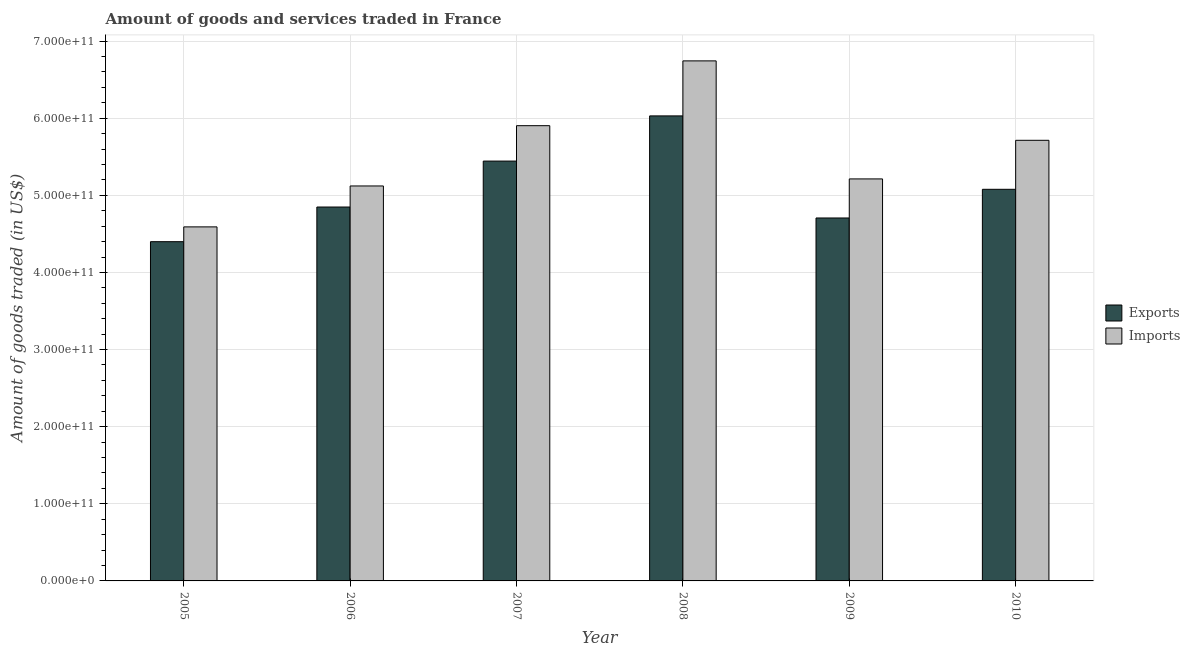How many different coloured bars are there?
Provide a short and direct response. 2. How many groups of bars are there?
Provide a succinct answer. 6. Are the number of bars on each tick of the X-axis equal?
Keep it short and to the point. Yes. How many bars are there on the 4th tick from the left?
Give a very brief answer. 2. How many bars are there on the 4th tick from the right?
Your answer should be compact. 2. What is the amount of goods imported in 2009?
Provide a succinct answer. 5.21e+11. Across all years, what is the maximum amount of goods exported?
Ensure brevity in your answer.  6.03e+11. Across all years, what is the minimum amount of goods exported?
Give a very brief answer. 4.40e+11. What is the total amount of goods imported in the graph?
Your answer should be compact. 3.33e+12. What is the difference between the amount of goods exported in 2005 and that in 2006?
Keep it short and to the point. -4.50e+1. What is the difference between the amount of goods imported in 2008 and the amount of goods exported in 2007?
Make the answer very short. 8.40e+1. What is the average amount of goods exported per year?
Your response must be concise. 5.08e+11. In how many years, is the amount of goods imported greater than 260000000000 US$?
Offer a terse response. 6. What is the ratio of the amount of goods imported in 2006 to that in 2008?
Offer a terse response. 0.76. Is the amount of goods exported in 2008 less than that in 2010?
Provide a short and direct response. No. What is the difference between the highest and the second highest amount of goods exported?
Offer a terse response. 5.86e+1. What is the difference between the highest and the lowest amount of goods imported?
Provide a short and direct response. 2.15e+11. Is the sum of the amount of goods imported in 2007 and 2009 greater than the maximum amount of goods exported across all years?
Make the answer very short. Yes. What does the 1st bar from the left in 2010 represents?
Offer a very short reply. Exports. What does the 1st bar from the right in 2009 represents?
Give a very brief answer. Imports. Are all the bars in the graph horizontal?
Keep it short and to the point. No. What is the difference between two consecutive major ticks on the Y-axis?
Your response must be concise. 1.00e+11. Does the graph contain any zero values?
Offer a very short reply. No. Where does the legend appear in the graph?
Your answer should be compact. Center right. How many legend labels are there?
Give a very brief answer. 2. What is the title of the graph?
Offer a terse response. Amount of goods and services traded in France. Does "Female labor force" appear as one of the legend labels in the graph?
Make the answer very short. No. What is the label or title of the X-axis?
Provide a short and direct response. Year. What is the label or title of the Y-axis?
Your response must be concise. Amount of goods traded (in US$). What is the Amount of goods traded (in US$) in Exports in 2005?
Offer a terse response. 4.40e+11. What is the Amount of goods traded (in US$) of Imports in 2005?
Offer a very short reply. 4.59e+11. What is the Amount of goods traded (in US$) in Exports in 2006?
Give a very brief answer. 4.85e+11. What is the Amount of goods traded (in US$) of Imports in 2006?
Offer a very short reply. 5.12e+11. What is the Amount of goods traded (in US$) of Exports in 2007?
Keep it short and to the point. 5.44e+11. What is the Amount of goods traded (in US$) in Imports in 2007?
Give a very brief answer. 5.90e+11. What is the Amount of goods traded (in US$) in Exports in 2008?
Your answer should be very brief. 6.03e+11. What is the Amount of goods traded (in US$) in Imports in 2008?
Provide a succinct answer. 6.74e+11. What is the Amount of goods traded (in US$) in Exports in 2009?
Provide a succinct answer. 4.71e+11. What is the Amount of goods traded (in US$) of Imports in 2009?
Provide a short and direct response. 5.21e+11. What is the Amount of goods traded (in US$) of Exports in 2010?
Your answer should be compact. 5.08e+11. What is the Amount of goods traded (in US$) in Imports in 2010?
Your response must be concise. 5.71e+11. Across all years, what is the maximum Amount of goods traded (in US$) of Exports?
Make the answer very short. 6.03e+11. Across all years, what is the maximum Amount of goods traded (in US$) in Imports?
Give a very brief answer. 6.74e+11. Across all years, what is the minimum Amount of goods traded (in US$) of Exports?
Keep it short and to the point. 4.40e+11. Across all years, what is the minimum Amount of goods traded (in US$) of Imports?
Provide a succinct answer. 4.59e+11. What is the total Amount of goods traded (in US$) in Exports in the graph?
Give a very brief answer. 3.05e+12. What is the total Amount of goods traded (in US$) of Imports in the graph?
Your response must be concise. 3.33e+12. What is the difference between the Amount of goods traded (in US$) in Exports in 2005 and that in 2006?
Your response must be concise. -4.50e+1. What is the difference between the Amount of goods traded (in US$) of Imports in 2005 and that in 2006?
Keep it short and to the point. -5.30e+1. What is the difference between the Amount of goods traded (in US$) of Exports in 2005 and that in 2007?
Provide a succinct answer. -1.05e+11. What is the difference between the Amount of goods traded (in US$) of Imports in 2005 and that in 2007?
Offer a terse response. -1.31e+11. What is the difference between the Amount of goods traded (in US$) of Exports in 2005 and that in 2008?
Your answer should be very brief. -1.63e+11. What is the difference between the Amount of goods traded (in US$) of Imports in 2005 and that in 2008?
Keep it short and to the point. -2.15e+11. What is the difference between the Amount of goods traded (in US$) in Exports in 2005 and that in 2009?
Offer a very short reply. -3.07e+1. What is the difference between the Amount of goods traded (in US$) in Imports in 2005 and that in 2009?
Ensure brevity in your answer.  -6.22e+1. What is the difference between the Amount of goods traded (in US$) of Exports in 2005 and that in 2010?
Your response must be concise. -6.79e+1. What is the difference between the Amount of goods traded (in US$) in Imports in 2005 and that in 2010?
Provide a short and direct response. -1.12e+11. What is the difference between the Amount of goods traded (in US$) in Exports in 2006 and that in 2007?
Keep it short and to the point. -5.96e+1. What is the difference between the Amount of goods traded (in US$) in Imports in 2006 and that in 2007?
Your answer should be compact. -7.82e+1. What is the difference between the Amount of goods traded (in US$) of Exports in 2006 and that in 2008?
Offer a very short reply. -1.18e+11. What is the difference between the Amount of goods traded (in US$) in Imports in 2006 and that in 2008?
Keep it short and to the point. -1.62e+11. What is the difference between the Amount of goods traded (in US$) in Exports in 2006 and that in 2009?
Provide a short and direct response. 1.42e+1. What is the difference between the Amount of goods traded (in US$) of Imports in 2006 and that in 2009?
Provide a short and direct response. -9.15e+09. What is the difference between the Amount of goods traded (in US$) of Exports in 2006 and that in 2010?
Your response must be concise. -2.30e+1. What is the difference between the Amount of goods traded (in US$) in Imports in 2006 and that in 2010?
Your response must be concise. -5.92e+1. What is the difference between the Amount of goods traded (in US$) in Exports in 2007 and that in 2008?
Provide a succinct answer. -5.86e+1. What is the difference between the Amount of goods traded (in US$) in Imports in 2007 and that in 2008?
Offer a very short reply. -8.40e+1. What is the difference between the Amount of goods traded (in US$) in Exports in 2007 and that in 2009?
Your answer should be very brief. 7.38e+1. What is the difference between the Amount of goods traded (in US$) in Imports in 2007 and that in 2009?
Ensure brevity in your answer.  6.90e+1. What is the difference between the Amount of goods traded (in US$) in Exports in 2007 and that in 2010?
Your answer should be very brief. 3.66e+1. What is the difference between the Amount of goods traded (in US$) in Imports in 2007 and that in 2010?
Give a very brief answer. 1.90e+1. What is the difference between the Amount of goods traded (in US$) in Exports in 2008 and that in 2009?
Provide a short and direct response. 1.32e+11. What is the difference between the Amount of goods traded (in US$) of Imports in 2008 and that in 2009?
Give a very brief answer. 1.53e+11. What is the difference between the Amount of goods traded (in US$) of Exports in 2008 and that in 2010?
Offer a very short reply. 9.52e+1. What is the difference between the Amount of goods traded (in US$) of Imports in 2008 and that in 2010?
Your answer should be compact. 1.03e+11. What is the difference between the Amount of goods traded (in US$) of Exports in 2009 and that in 2010?
Give a very brief answer. -3.72e+1. What is the difference between the Amount of goods traded (in US$) of Imports in 2009 and that in 2010?
Offer a terse response. -5.01e+1. What is the difference between the Amount of goods traded (in US$) of Exports in 2005 and the Amount of goods traded (in US$) of Imports in 2006?
Provide a succinct answer. -7.23e+1. What is the difference between the Amount of goods traded (in US$) of Exports in 2005 and the Amount of goods traded (in US$) of Imports in 2007?
Your response must be concise. -1.50e+11. What is the difference between the Amount of goods traded (in US$) of Exports in 2005 and the Amount of goods traded (in US$) of Imports in 2008?
Provide a succinct answer. -2.34e+11. What is the difference between the Amount of goods traded (in US$) in Exports in 2005 and the Amount of goods traded (in US$) in Imports in 2009?
Keep it short and to the point. -8.14e+1. What is the difference between the Amount of goods traded (in US$) of Exports in 2005 and the Amount of goods traded (in US$) of Imports in 2010?
Provide a short and direct response. -1.31e+11. What is the difference between the Amount of goods traded (in US$) in Exports in 2006 and the Amount of goods traded (in US$) in Imports in 2007?
Your answer should be very brief. -1.05e+11. What is the difference between the Amount of goods traded (in US$) of Exports in 2006 and the Amount of goods traded (in US$) of Imports in 2008?
Offer a terse response. -1.90e+11. What is the difference between the Amount of goods traded (in US$) of Exports in 2006 and the Amount of goods traded (in US$) of Imports in 2009?
Give a very brief answer. -3.64e+1. What is the difference between the Amount of goods traded (in US$) of Exports in 2006 and the Amount of goods traded (in US$) of Imports in 2010?
Offer a very short reply. -8.65e+1. What is the difference between the Amount of goods traded (in US$) of Exports in 2007 and the Amount of goods traded (in US$) of Imports in 2008?
Give a very brief answer. -1.30e+11. What is the difference between the Amount of goods traded (in US$) in Exports in 2007 and the Amount of goods traded (in US$) in Imports in 2009?
Offer a very short reply. 2.31e+1. What is the difference between the Amount of goods traded (in US$) in Exports in 2007 and the Amount of goods traded (in US$) in Imports in 2010?
Your response must be concise. -2.69e+1. What is the difference between the Amount of goods traded (in US$) in Exports in 2008 and the Amount of goods traded (in US$) in Imports in 2009?
Keep it short and to the point. 8.17e+1. What is the difference between the Amount of goods traded (in US$) in Exports in 2008 and the Amount of goods traded (in US$) in Imports in 2010?
Your answer should be very brief. 3.17e+1. What is the difference between the Amount of goods traded (in US$) of Exports in 2009 and the Amount of goods traded (in US$) of Imports in 2010?
Make the answer very short. -1.01e+11. What is the average Amount of goods traded (in US$) in Exports per year?
Make the answer very short. 5.08e+11. What is the average Amount of goods traded (in US$) of Imports per year?
Keep it short and to the point. 5.55e+11. In the year 2005, what is the difference between the Amount of goods traded (in US$) of Exports and Amount of goods traded (in US$) of Imports?
Provide a succinct answer. -1.92e+1. In the year 2006, what is the difference between the Amount of goods traded (in US$) of Exports and Amount of goods traded (in US$) of Imports?
Your answer should be compact. -2.73e+1. In the year 2007, what is the difference between the Amount of goods traded (in US$) in Exports and Amount of goods traded (in US$) in Imports?
Provide a succinct answer. -4.59e+1. In the year 2008, what is the difference between the Amount of goods traded (in US$) in Exports and Amount of goods traded (in US$) in Imports?
Offer a very short reply. -7.14e+1. In the year 2009, what is the difference between the Amount of goods traded (in US$) of Exports and Amount of goods traded (in US$) of Imports?
Offer a very short reply. -5.07e+1. In the year 2010, what is the difference between the Amount of goods traded (in US$) of Exports and Amount of goods traded (in US$) of Imports?
Give a very brief answer. -6.35e+1. What is the ratio of the Amount of goods traded (in US$) in Exports in 2005 to that in 2006?
Your response must be concise. 0.91. What is the ratio of the Amount of goods traded (in US$) in Imports in 2005 to that in 2006?
Ensure brevity in your answer.  0.9. What is the ratio of the Amount of goods traded (in US$) of Exports in 2005 to that in 2007?
Ensure brevity in your answer.  0.81. What is the ratio of the Amount of goods traded (in US$) in Imports in 2005 to that in 2007?
Make the answer very short. 0.78. What is the ratio of the Amount of goods traded (in US$) in Exports in 2005 to that in 2008?
Ensure brevity in your answer.  0.73. What is the ratio of the Amount of goods traded (in US$) in Imports in 2005 to that in 2008?
Give a very brief answer. 0.68. What is the ratio of the Amount of goods traded (in US$) in Exports in 2005 to that in 2009?
Provide a succinct answer. 0.93. What is the ratio of the Amount of goods traded (in US$) of Imports in 2005 to that in 2009?
Ensure brevity in your answer.  0.88. What is the ratio of the Amount of goods traded (in US$) in Exports in 2005 to that in 2010?
Offer a terse response. 0.87. What is the ratio of the Amount of goods traded (in US$) in Imports in 2005 to that in 2010?
Your answer should be compact. 0.8. What is the ratio of the Amount of goods traded (in US$) of Exports in 2006 to that in 2007?
Make the answer very short. 0.89. What is the ratio of the Amount of goods traded (in US$) in Imports in 2006 to that in 2007?
Offer a terse response. 0.87. What is the ratio of the Amount of goods traded (in US$) in Exports in 2006 to that in 2008?
Keep it short and to the point. 0.8. What is the ratio of the Amount of goods traded (in US$) of Imports in 2006 to that in 2008?
Offer a very short reply. 0.76. What is the ratio of the Amount of goods traded (in US$) in Exports in 2006 to that in 2009?
Offer a very short reply. 1.03. What is the ratio of the Amount of goods traded (in US$) of Imports in 2006 to that in 2009?
Give a very brief answer. 0.98. What is the ratio of the Amount of goods traded (in US$) in Exports in 2006 to that in 2010?
Provide a short and direct response. 0.95. What is the ratio of the Amount of goods traded (in US$) in Imports in 2006 to that in 2010?
Offer a terse response. 0.9. What is the ratio of the Amount of goods traded (in US$) in Exports in 2007 to that in 2008?
Your answer should be compact. 0.9. What is the ratio of the Amount of goods traded (in US$) of Imports in 2007 to that in 2008?
Provide a short and direct response. 0.88. What is the ratio of the Amount of goods traded (in US$) in Exports in 2007 to that in 2009?
Your answer should be very brief. 1.16. What is the ratio of the Amount of goods traded (in US$) in Imports in 2007 to that in 2009?
Ensure brevity in your answer.  1.13. What is the ratio of the Amount of goods traded (in US$) in Exports in 2007 to that in 2010?
Your response must be concise. 1.07. What is the ratio of the Amount of goods traded (in US$) of Imports in 2007 to that in 2010?
Give a very brief answer. 1.03. What is the ratio of the Amount of goods traded (in US$) in Exports in 2008 to that in 2009?
Provide a succinct answer. 1.28. What is the ratio of the Amount of goods traded (in US$) of Imports in 2008 to that in 2009?
Your answer should be very brief. 1.29. What is the ratio of the Amount of goods traded (in US$) of Exports in 2008 to that in 2010?
Keep it short and to the point. 1.19. What is the ratio of the Amount of goods traded (in US$) in Imports in 2008 to that in 2010?
Ensure brevity in your answer.  1.18. What is the ratio of the Amount of goods traded (in US$) in Exports in 2009 to that in 2010?
Ensure brevity in your answer.  0.93. What is the ratio of the Amount of goods traded (in US$) in Imports in 2009 to that in 2010?
Offer a very short reply. 0.91. What is the difference between the highest and the second highest Amount of goods traded (in US$) in Exports?
Your answer should be very brief. 5.86e+1. What is the difference between the highest and the second highest Amount of goods traded (in US$) in Imports?
Ensure brevity in your answer.  8.40e+1. What is the difference between the highest and the lowest Amount of goods traded (in US$) in Exports?
Give a very brief answer. 1.63e+11. What is the difference between the highest and the lowest Amount of goods traded (in US$) of Imports?
Offer a very short reply. 2.15e+11. 